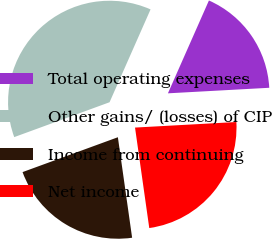Convert chart. <chart><loc_0><loc_0><loc_500><loc_500><pie_chart><fcel>Total operating expenses<fcel>Other gains/ (losses) of CIP<fcel>Income from continuing<fcel>Net income<nl><fcel>17.51%<fcel>37.2%<fcel>21.66%<fcel>23.63%<nl></chart> 